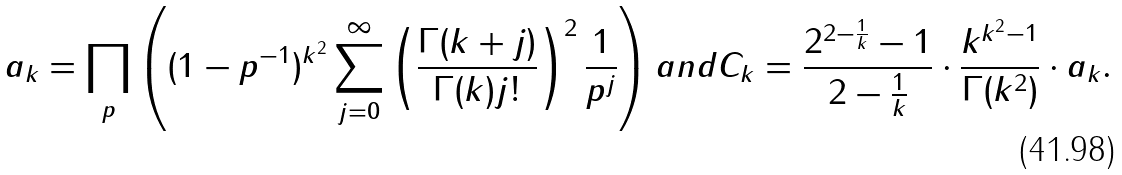<formula> <loc_0><loc_0><loc_500><loc_500>a _ { k } = \prod _ { p } \left ( ( 1 - p ^ { - 1 } ) ^ { k ^ { 2 } } \sum _ { j = 0 } ^ { \infty } \left ( \frac { \Gamma ( k + j ) } { \Gamma ( k ) j ! } \right ) ^ { 2 } \frac { 1 } { p ^ { j } } \right ) a n d C _ { k } = \frac { 2 ^ { 2 - \frac { 1 } { k } } - 1 } { 2 - \frac { 1 } { k } } \cdot \frac { k ^ { k ^ { 2 } - 1 } } { \Gamma ( k ^ { 2 } ) } \cdot a _ { k } .</formula> 